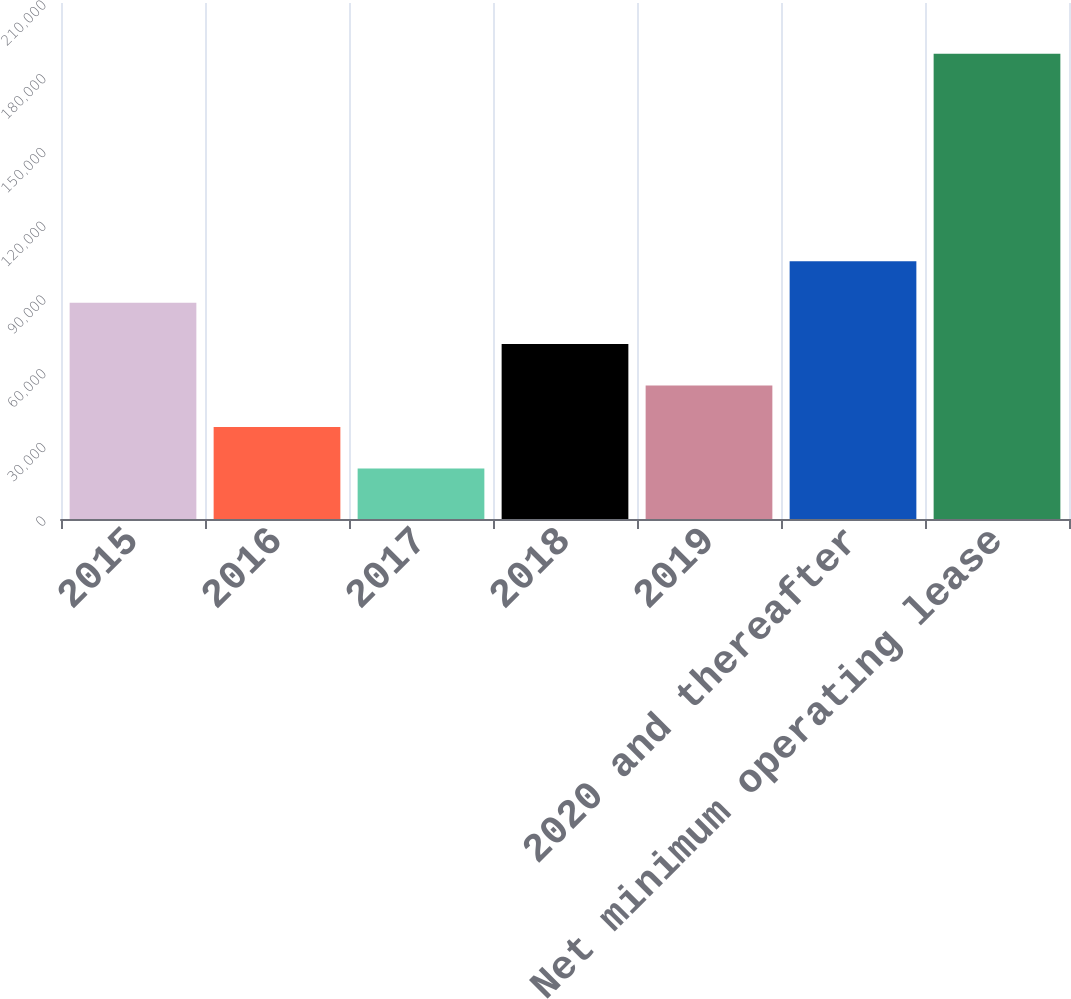Convert chart to OTSL. <chart><loc_0><loc_0><loc_500><loc_500><bar_chart><fcel>2015<fcel>2016<fcel>2017<fcel>2018<fcel>2019<fcel>2020 and thereafter<fcel>Net minimum operating lease<nl><fcel>88057.2<fcel>37396.8<fcel>20510<fcel>71170.4<fcel>54283.6<fcel>104944<fcel>189378<nl></chart> 